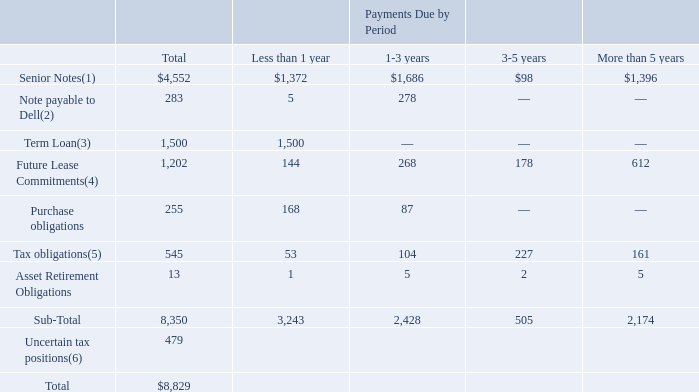Contractual Obligations
We have various contractual obligations impacting our liquidity. The following represents our contractual obligations as of January 31, 2020 (table in millions)
(1) Consists of principal and interest payments on the Senior Notes. Refer to “Liquidity and Capital Resources” for a discussion of the public debt offering we issued on August 21, 2017 in the aggregate principal amount of $4.0 billion.
(2) Consists of principal and interest payments on the outstanding note payable to Dell. Refer to “Liquidity and Capital Resources” for a discussion of the $270 million note payable we entered into with Dell per the note exchange agreement from January 21, 2014.
(3) Consists of the principal on the senior unsecured term loan facility (the “Term Loan”). The Term Loan can be repaid any time before October 2020. Given the variable nature of the interest on the Term Loan, including when the repayment will take place, interest payments have been excluded from the table above.
(4) Consists of both operating and finance leases. Our operating leases are primarily for facility space and land. Amounts in the table above exclude legally binding minimum lease payments for leases signed but not yet commenced of $361 million, as well as expected sublease income.
(5) Consists of future cash payments related to the Transition Tax.
(6) As of January 31, 2020, we had $479 million of gross uncertain tax benefits, excluding interest and penalties. The timing of future payments relating to these obligations is highly uncertain. Based on the timing and outcome of examinations of our subsidiaries, the result of the expiration of statutes of limitations for specific jurisdictions or the timing and result of ruling requests from taxing authorities, it is reasonably possible that within the next 12 months total unrecognized tax benefits could be potentially reduced by approximately $17 million.
What did the Senior Notes consists of? Principal and interest payments on the senior notes. What was the total term loans?
Answer scale should be: million. 1,500. What were the total future lease commitments?
Answer scale should be: million. 1,202. What was the difference between total Senior Notes and total Notes payable to Dell?
Answer scale should be: million. 4,552-283
Answer: 4269. What was the difference between total Term Loans and total Future Lease Commitments?
Answer scale should be: million. 1,500-1,202
Answer: 298. What was the total Senior Notes as a percentage of total contractual obligations?
Answer scale should be: percent. 4,552/8,829
Answer: 51.56. 